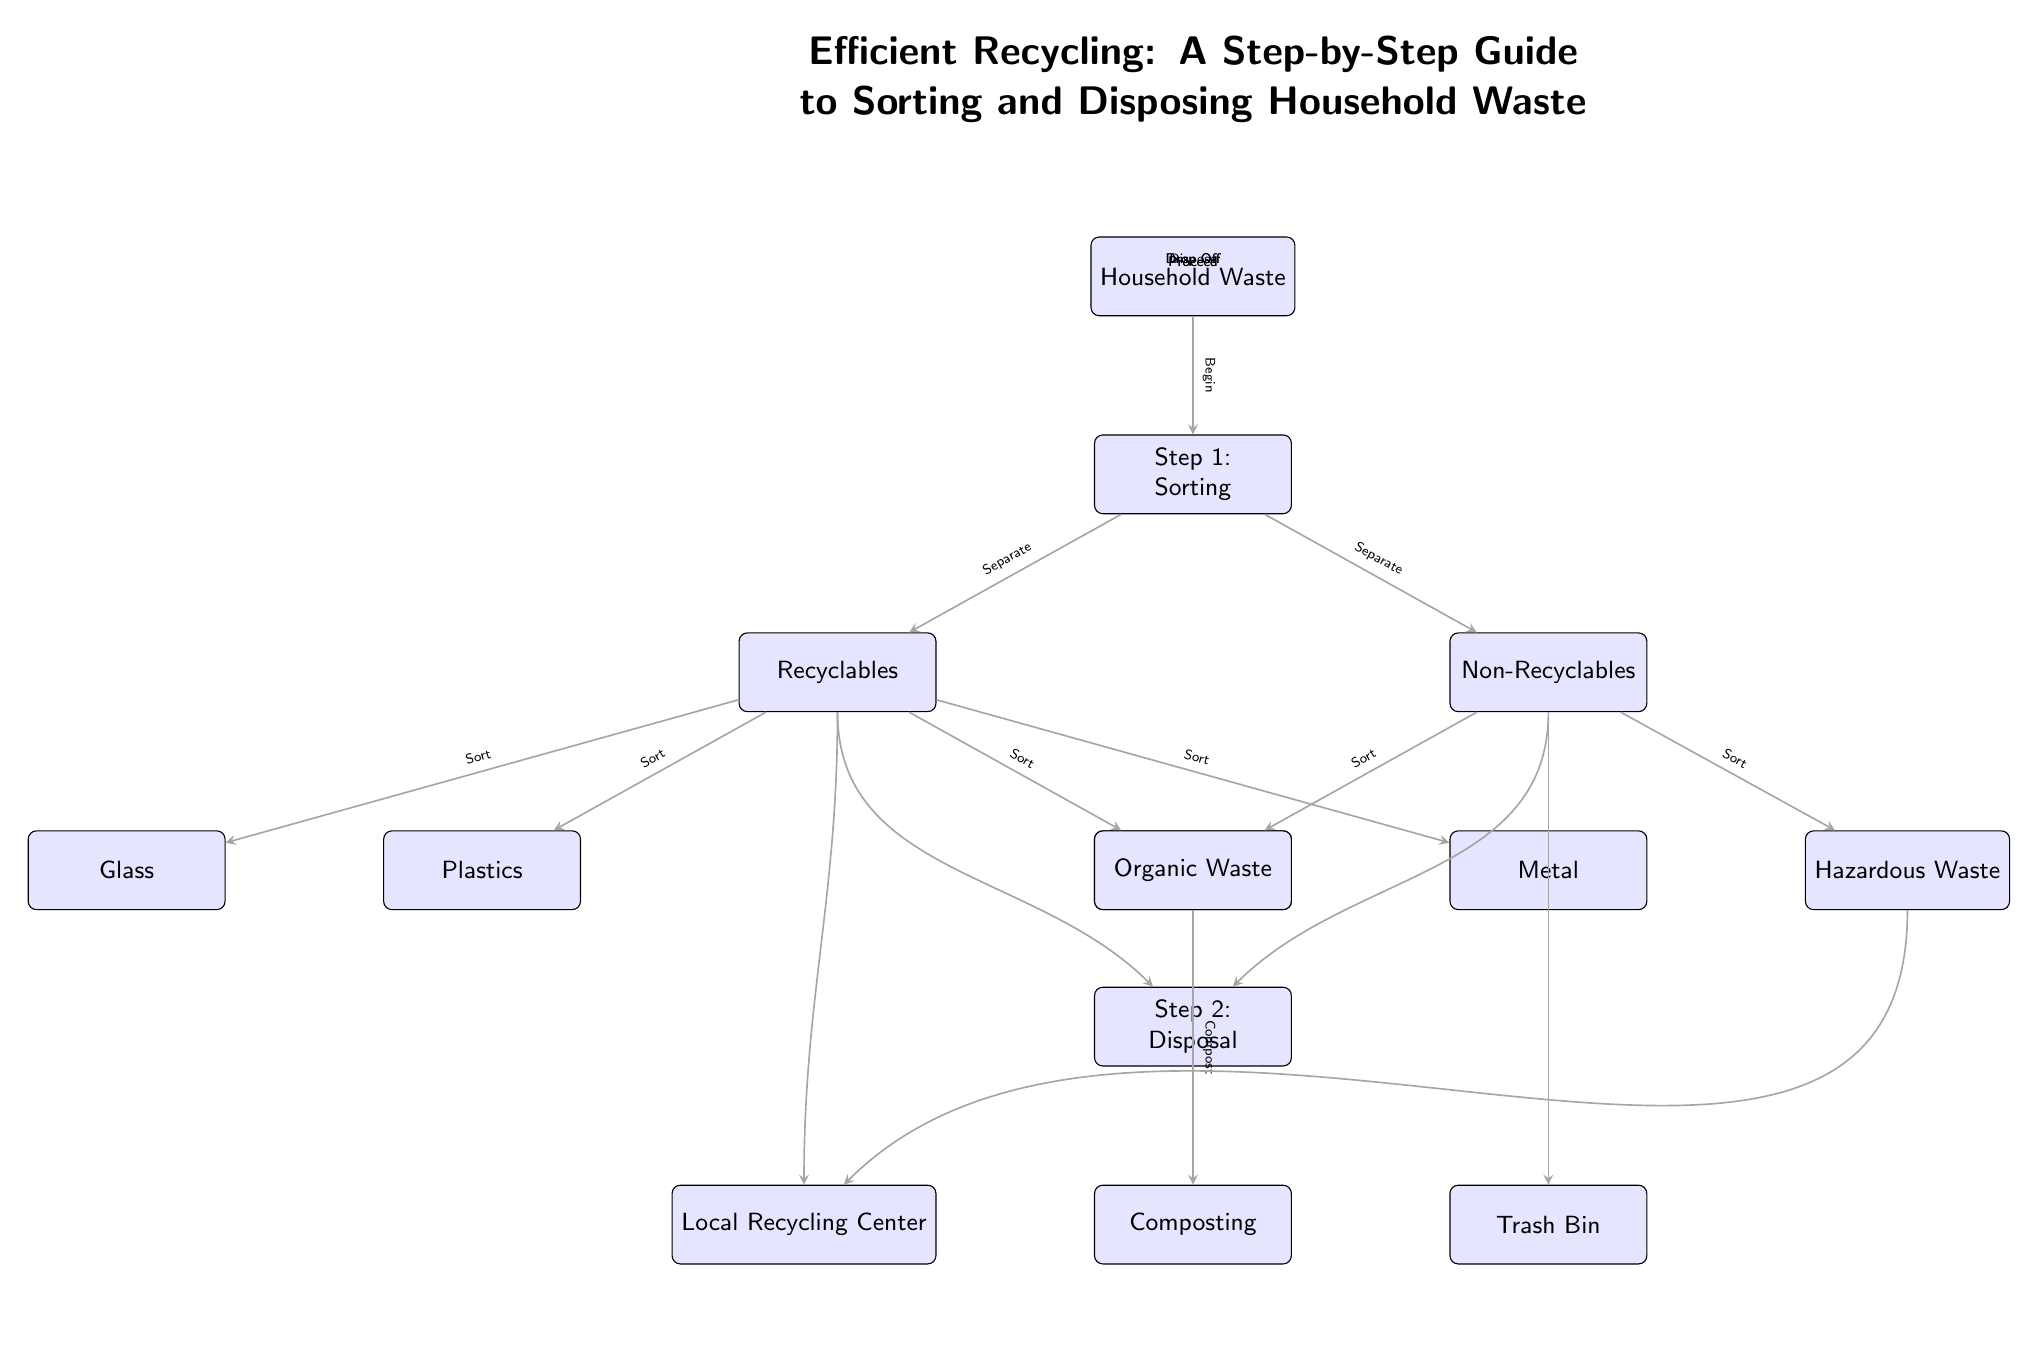What is the first step in the recycling process? The diagram indicates that the first step in the recycling process is labeled as "Step 1: Sorting." It is directly connected to the "Household Waste" node.
Answer: Sorting How many types of recyclables are listed? The diagram shows four types of recyclables: Plastics, Glass, Paper, and Metal. These are the nodes under the "Recyclables" section connected to the "Sorting" step.
Answer: Four What is done with organic waste? According to the diagram, organic waste is directed to "Composting," which is a disposal method indicated under "Step 2: Disposal" connected to the "Non-Recyclables" section.
Answer: Composting Which two types of waste go to the local recycling center? The diagram shows that both Plastics and Hazardous Waste are directed to the "Local Recycling Center." These are nodes under Recyclables and Non-Recyclables respectively, indicating they proceed there for proper disposal.
Answer: Plastics and Hazardous Waste How do non-recyclables reach the trash bin? Non-recyclables, once sorted, are directed straight to the "Trash Bin" node from the "Non-Recyclables" area. This is shown as a straight path leading directly downward from that node.
Answer: Dispose What action is taken after separating recyclables and non-recyclables? After separating the two categories, the diagram indicates a common action labeled "Proceed," which connects both the "Recyclables" and "Non-Recyclables" to the next step named "Step 2: Disposal."
Answer: Proceed What is the label for the second step in the process? The diagram clearly marks the second step as "Step 2: Disposal." This is positioned below the sorting step and indicates what to do with the sorted waste.
Answer: Disposal How many disposal methods are indicated for recyclables? The diagram specifies two disposal methods for recyclables: "Local Recycling Center" and "Trash Bin," showing where the sorted recyclables are directed.
Answer: Two 